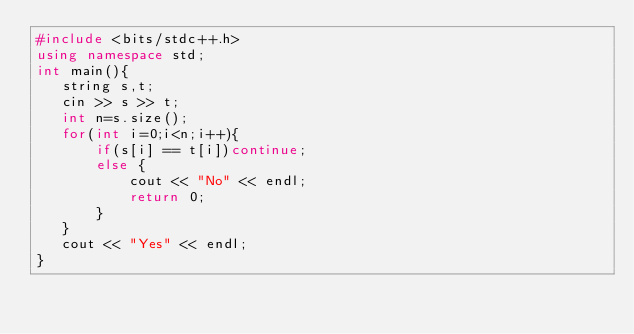<code> <loc_0><loc_0><loc_500><loc_500><_C++_>#include <bits/stdc++.h>
using namespace std;
int main(){
   string s,t;
   cin >> s >> t;
   int n=s.size();
   for(int i=0;i<n;i++){
       if(s[i] == t[i])continue;
       else {
           cout << "No" << endl;
           return 0;
       }
   }
   cout << "Yes" << endl;
}
</code> 